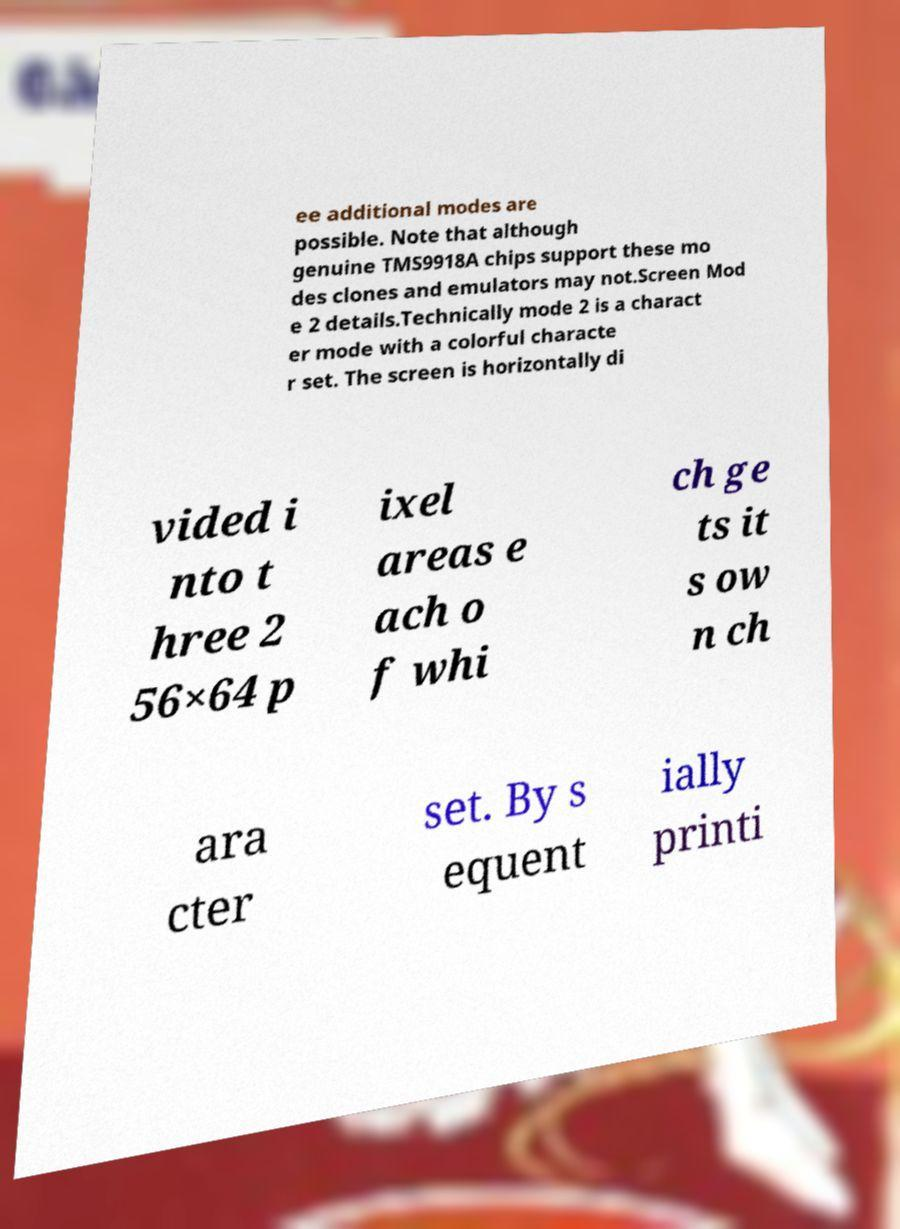Can you read and provide the text displayed in the image?This photo seems to have some interesting text. Can you extract and type it out for me? ee additional modes are possible. Note that although genuine TMS9918A chips support these mo des clones and emulators may not.Screen Mod e 2 details.Technically mode 2 is a charact er mode with a colorful characte r set. The screen is horizontally di vided i nto t hree 2 56×64 p ixel areas e ach o f whi ch ge ts it s ow n ch ara cter set. By s equent ially printi 